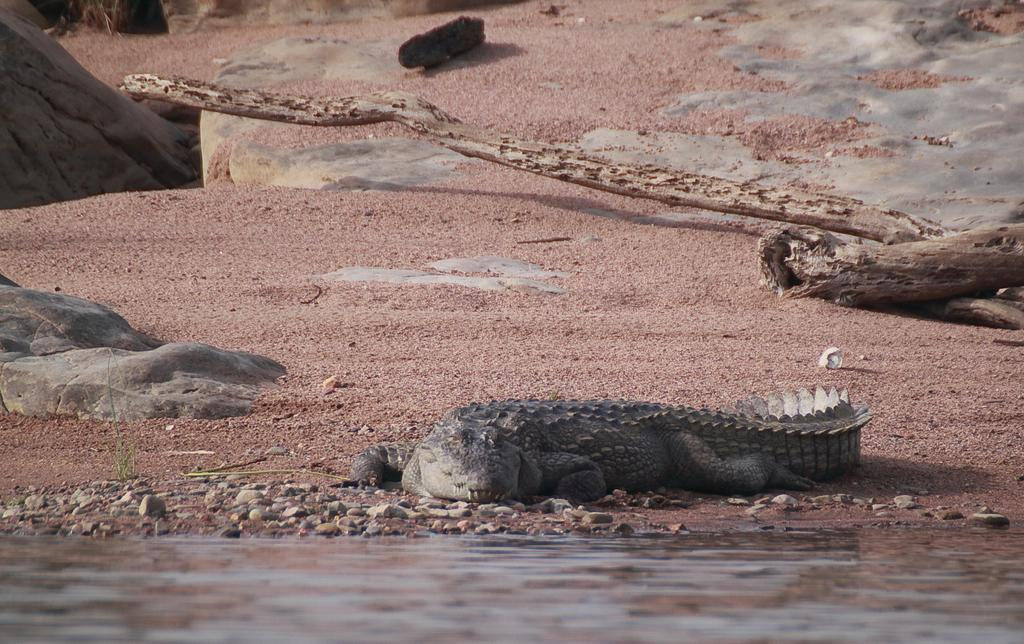What type of animal is in the image? There is an alligator in the image. What type of natural materials are present in the image? There are wooden logs, stones, and sand in the image. What is the liquid element in the image? There is water in the image. Can you provide an example of a receipt in the image? There is no receipt present in the image; it features an alligator, wooden logs, stones, sand, and water. 